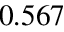<formula> <loc_0><loc_0><loc_500><loc_500>0 . 5 6 7</formula> 